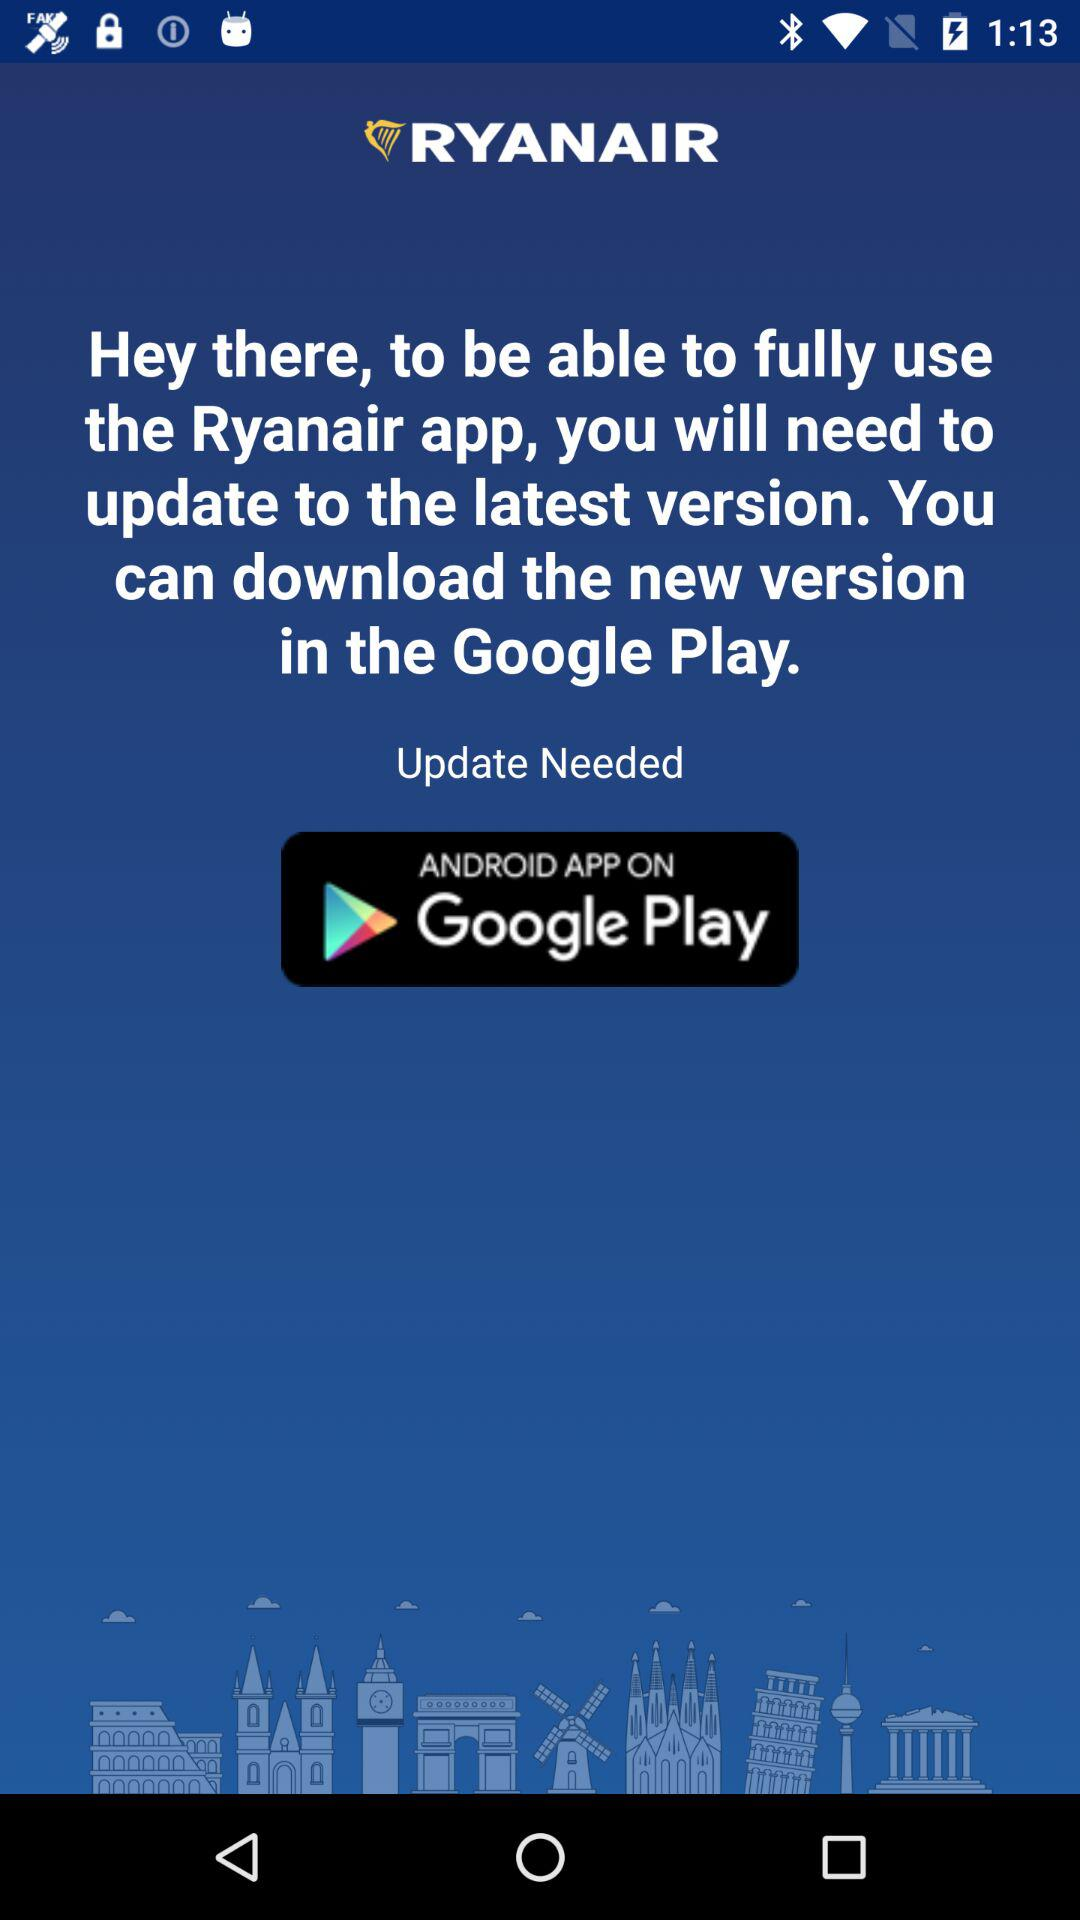What is the name of the application? The name of the application is "RYANAIR". 